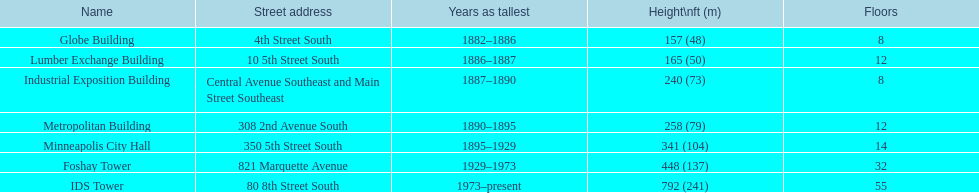What is the loftiest edifice? IDS Tower. 